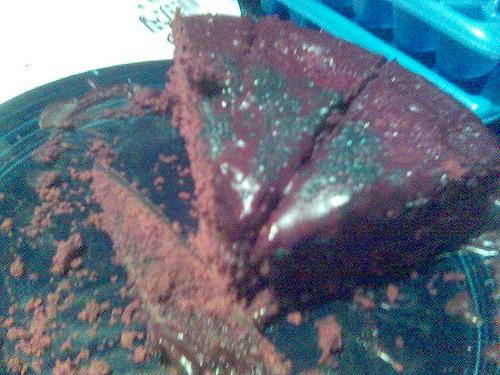How many slices are left?
Answer briefly. 2. What kind of cake is that?
Quick response, please. Chocolate. Is it a birthday?
Give a very brief answer. Yes. 